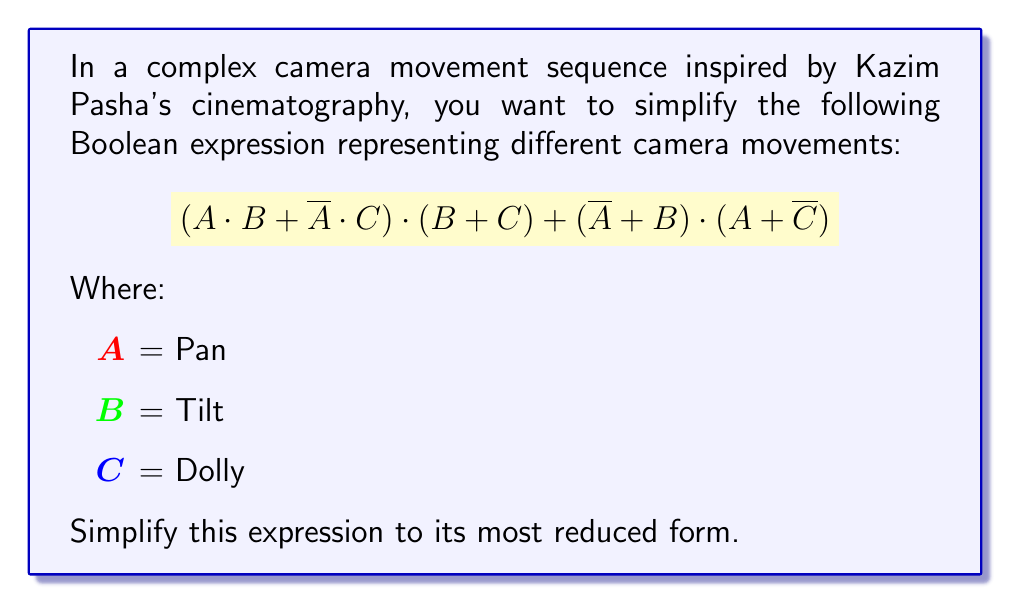Provide a solution to this math problem. Let's simplify this expression step by step:

1) First, let's distribute the terms in the first part:
   $$(A \cdot B + \overline{A} \cdot C) \cdot (B + C) = A \cdot B \cdot B + A \cdot B \cdot C + \overline{A} \cdot C \cdot B + \overline{A} \cdot C \cdot C$$

2) Simplify using the idempotent law (X · X = X):
   $$A \cdot B + A \cdot B \cdot C + \overline{A} \cdot C \cdot B + \overline{A} \cdot C$$

3) Now, let's distribute the terms in the second part:
   $$(\overline{A} + B) \cdot (A + \overline{C}) = \overline{A} \cdot A + \overline{A} \cdot \overline{C} + B \cdot A + B \cdot \overline{C}$$

4) Simplify using the complement law (X · $\overline{X}$ = 0):
   $$\overline{A} \cdot \overline{C} + B \cdot A + B \cdot \overline{C}$$

5) Now we have:
   $$(A \cdot B + A \cdot B \cdot C + \overline{A} \cdot C \cdot B + \overline{A} \cdot C) + (\overline{A} \cdot \overline{C} + B \cdot A + B \cdot \overline{C})$$

6) Rearrange terms:
   $$A \cdot B + A \cdot B \cdot C + \overline{A} \cdot C \cdot B + \overline{A} \cdot C + \overline{A} \cdot \overline{C} + B \cdot A + B \cdot \overline{C}$$

7) Combine like terms:
   $$A \cdot B + \overline{A} \cdot C + \overline{A} \cdot \overline{C} + B \cdot \overline{C}$$

8) Use the distributive law:
   $$A \cdot B + \overline{A} \cdot (C + \overline{C}) + B \cdot \overline{C}$$

9) Simplify using the complement law (X + $\overline{X}$ = 1):
   $$A \cdot B + \overline{A} + B \cdot \overline{C}$$

10) This is the most reduced form of the expression.
Answer: $$A \cdot B + \overline{A} + B \cdot \overline{C}$$ 